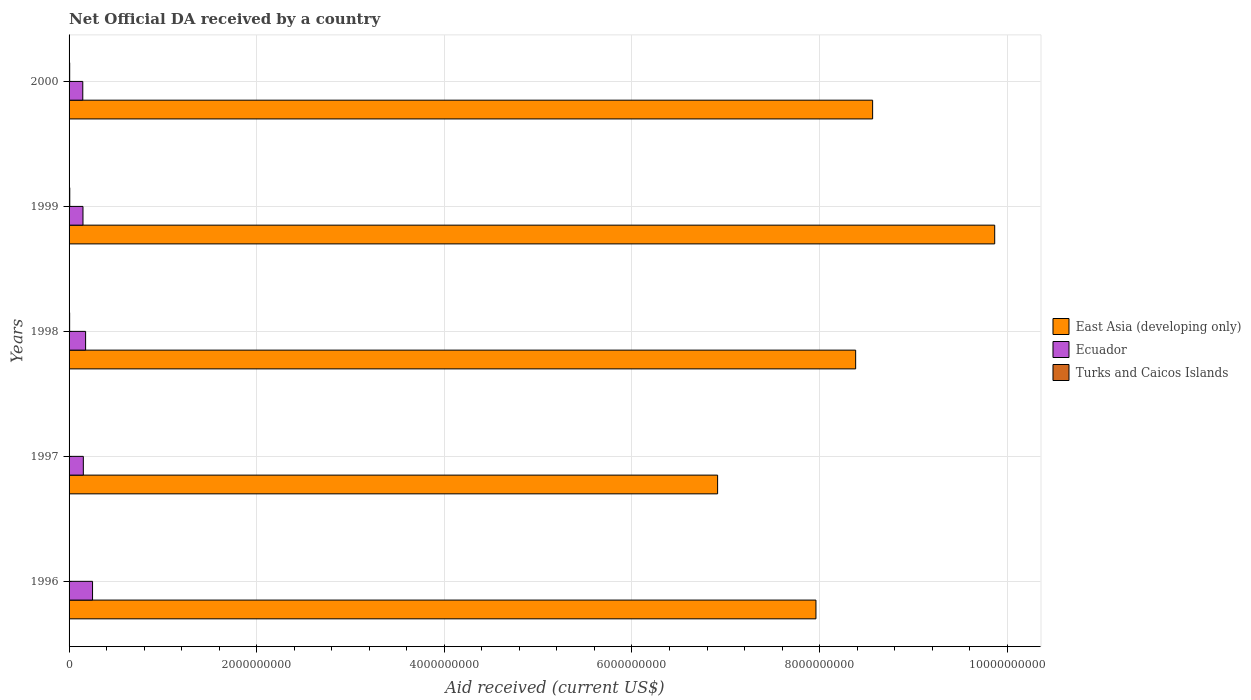What is the net official development assistance aid received in Turks and Caicos Islands in 2000?
Keep it short and to the point. 6.65e+06. Across all years, what is the maximum net official development assistance aid received in East Asia (developing only)?
Your response must be concise. 9.87e+09. Across all years, what is the minimum net official development assistance aid received in Ecuador?
Provide a short and direct response. 1.46e+08. In which year was the net official development assistance aid received in Turks and Caicos Islands maximum?
Provide a succinct answer. 1999. What is the total net official development assistance aid received in Turks and Caicos Islands in the graph?
Offer a very short reply. 2.84e+07. What is the difference between the net official development assistance aid received in East Asia (developing only) in 1996 and that in 2000?
Your answer should be compact. -6.04e+08. What is the difference between the net official development assistance aid received in Turks and Caicos Islands in 1998 and the net official development assistance aid received in East Asia (developing only) in 1999?
Ensure brevity in your answer.  -9.86e+09. What is the average net official development assistance aid received in Turks and Caicos Islands per year?
Keep it short and to the point. 5.69e+06. In the year 2000, what is the difference between the net official development assistance aid received in Ecuador and net official development assistance aid received in East Asia (developing only)?
Give a very brief answer. -8.42e+09. What is the ratio of the net official development assistance aid received in Turks and Caicos Islands in 1996 to that in 2000?
Provide a short and direct response. 0.63. Is the difference between the net official development assistance aid received in Ecuador in 1998 and 1999 greater than the difference between the net official development assistance aid received in East Asia (developing only) in 1998 and 1999?
Your response must be concise. Yes. What is the difference between the highest and the second highest net official development assistance aid received in Ecuador?
Provide a succinct answer. 7.38e+07. What is the difference between the highest and the lowest net official development assistance aid received in Turks and Caicos Islands?
Provide a short and direct response. 3.20e+06. What does the 3rd bar from the top in 1997 represents?
Offer a very short reply. East Asia (developing only). What does the 1st bar from the bottom in 1999 represents?
Your answer should be compact. East Asia (developing only). How many years are there in the graph?
Offer a terse response. 5. What is the difference between two consecutive major ticks on the X-axis?
Keep it short and to the point. 2.00e+09. Are the values on the major ticks of X-axis written in scientific E-notation?
Your response must be concise. No. Does the graph contain any zero values?
Offer a very short reply. No. How many legend labels are there?
Offer a terse response. 3. What is the title of the graph?
Offer a terse response. Net Official DA received by a country. Does "Sub-Saharan Africa (developing only)" appear as one of the legend labels in the graph?
Provide a succinct answer. No. What is the label or title of the X-axis?
Provide a succinct answer. Aid received (current US$). What is the label or title of the Y-axis?
Offer a very short reply. Years. What is the Aid received (current US$) of East Asia (developing only) in 1996?
Offer a terse response. 7.96e+09. What is the Aid received (current US$) of Ecuador in 1996?
Provide a short and direct response. 2.50e+08. What is the Aid received (current US$) of Turks and Caicos Islands in 1996?
Your response must be concise. 4.18e+06. What is the Aid received (current US$) of East Asia (developing only) in 1997?
Give a very brief answer. 6.91e+09. What is the Aid received (current US$) in Ecuador in 1997?
Your answer should be compact. 1.52e+08. What is the Aid received (current US$) of Turks and Caicos Islands in 1997?
Your answer should be very brief. 4.20e+06. What is the Aid received (current US$) in East Asia (developing only) in 1998?
Provide a succinct answer. 8.38e+09. What is the Aid received (current US$) in Ecuador in 1998?
Keep it short and to the point. 1.76e+08. What is the Aid received (current US$) of Turks and Caicos Islands in 1998?
Your response must be concise. 6.02e+06. What is the Aid received (current US$) of East Asia (developing only) in 1999?
Provide a succinct answer. 9.87e+09. What is the Aid received (current US$) of Ecuador in 1999?
Give a very brief answer. 1.48e+08. What is the Aid received (current US$) in Turks and Caicos Islands in 1999?
Make the answer very short. 7.38e+06. What is the Aid received (current US$) in East Asia (developing only) in 2000?
Offer a very short reply. 8.57e+09. What is the Aid received (current US$) in Ecuador in 2000?
Your answer should be very brief. 1.46e+08. What is the Aid received (current US$) in Turks and Caicos Islands in 2000?
Keep it short and to the point. 6.65e+06. Across all years, what is the maximum Aid received (current US$) of East Asia (developing only)?
Your response must be concise. 9.87e+09. Across all years, what is the maximum Aid received (current US$) in Ecuador?
Ensure brevity in your answer.  2.50e+08. Across all years, what is the maximum Aid received (current US$) of Turks and Caicos Islands?
Provide a short and direct response. 7.38e+06. Across all years, what is the minimum Aid received (current US$) of East Asia (developing only)?
Your answer should be compact. 6.91e+09. Across all years, what is the minimum Aid received (current US$) in Ecuador?
Offer a very short reply. 1.46e+08. Across all years, what is the minimum Aid received (current US$) of Turks and Caicos Islands?
Keep it short and to the point. 4.18e+06. What is the total Aid received (current US$) in East Asia (developing only) in the graph?
Ensure brevity in your answer.  4.17e+1. What is the total Aid received (current US$) in Ecuador in the graph?
Keep it short and to the point. 8.73e+08. What is the total Aid received (current US$) in Turks and Caicos Islands in the graph?
Your response must be concise. 2.84e+07. What is the difference between the Aid received (current US$) in East Asia (developing only) in 1996 and that in 1997?
Provide a short and direct response. 1.05e+09. What is the difference between the Aid received (current US$) of Ecuador in 1996 and that in 1997?
Give a very brief answer. 9.82e+07. What is the difference between the Aid received (current US$) of Turks and Caicos Islands in 1996 and that in 1997?
Make the answer very short. -2.00e+04. What is the difference between the Aid received (current US$) of East Asia (developing only) in 1996 and that in 1998?
Give a very brief answer. -4.23e+08. What is the difference between the Aid received (current US$) in Ecuador in 1996 and that in 1998?
Offer a terse response. 7.38e+07. What is the difference between the Aid received (current US$) in Turks and Caicos Islands in 1996 and that in 1998?
Your answer should be compact. -1.84e+06. What is the difference between the Aid received (current US$) in East Asia (developing only) in 1996 and that in 1999?
Offer a terse response. -1.91e+09. What is the difference between the Aid received (current US$) in Ecuador in 1996 and that in 1999?
Offer a very short reply. 1.02e+08. What is the difference between the Aid received (current US$) of Turks and Caicos Islands in 1996 and that in 1999?
Your answer should be very brief. -3.20e+06. What is the difference between the Aid received (current US$) in East Asia (developing only) in 1996 and that in 2000?
Provide a short and direct response. -6.04e+08. What is the difference between the Aid received (current US$) in Ecuador in 1996 and that in 2000?
Your response must be concise. 1.04e+08. What is the difference between the Aid received (current US$) of Turks and Caicos Islands in 1996 and that in 2000?
Make the answer very short. -2.47e+06. What is the difference between the Aid received (current US$) in East Asia (developing only) in 1997 and that in 1998?
Give a very brief answer. -1.47e+09. What is the difference between the Aid received (current US$) in Ecuador in 1997 and that in 1998?
Give a very brief answer. -2.43e+07. What is the difference between the Aid received (current US$) in Turks and Caicos Islands in 1997 and that in 1998?
Keep it short and to the point. -1.82e+06. What is the difference between the Aid received (current US$) in East Asia (developing only) in 1997 and that in 1999?
Keep it short and to the point. -2.95e+09. What is the difference between the Aid received (current US$) of Ecuador in 1997 and that in 1999?
Your answer should be very brief. 3.79e+06. What is the difference between the Aid received (current US$) of Turks and Caicos Islands in 1997 and that in 1999?
Keep it short and to the point. -3.18e+06. What is the difference between the Aid received (current US$) in East Asia (developing only) in 1997 and that in 2000?
Your response must be concise. -1.65e+09. What is the difference between the Aid received (current US$) of Ecuador in 1997 and that in 2000?
Your response must be concise. 5.88e+06. What is the difference between the Aid received (current US$) in Turks and Caicos Islands in 1997 and that in 2000?
Your response must be concise. -2.45e+06. What is the difference between the Aid received (current US$) of East Asia (developing only) in 1998 and that in 1999?
Your answer should be very brief. -1.48e+09. What is the difference between the Aid received (current US$) of Ecuador in 1998 and that in 1999?
Ensure brevity in your answer.  2.81e+07. What is the difference between the Aid received (current US$) in Turks and Caicos Islands in 1998 and that in 1999?
Your response must be concise. -1.36e+06. What is the difference between the Aid received (current US$) in East Asia (developing only) in 1998 and that in 2000?
Your response must be concise. -1.81e+08. What is the difference between the Aid received (current US$) in Ecuador in 1998 and that in 2000?
Ensure brevity in your answer.  3.02e+07. What is the difference between the Aid received (current US$) of Turks and Caicos Islands in 1998 and that in 2000?
Offer a terse response. -6.30e+05. What is the difference between the Aid received (current US$) of East Asia (developing only) in 1999 and that in 2000?
Offer a terse response. 1.30e+09. What is the difference between the Aid received (current US$) of Ecuador in 1999 and that in 2000?
Provide a succinct answer. 2.09e+06. What is the difference between the Aid received (current US$) of Turks and Caicos Islands in 1999 and that in 2000?
Offer a terse response. 7.30e+05. What is the difference between the Aid received (current US$) in East Asia (developing only) in 1996 and the Aid received (current US$) in Ecuador in 1997?
Your answer should be compact. 7.81e+09. What is the difference between the Aid received (current US$) in East Asia (developing only) in 1996 and the Aid received (current US$) in Turks and Caicos Islands in 1997?
Make the answer very short. 7.96e+09. What is the difference between the Aid received (current US$) in Ecuador in 1996 and the Aid received (current US$) in Turks and Caicos Islands in 1997?
Your response must be concise. 2.46e+08. What is the difference between the Aid received (current US$) of East Asia (developing only) in 1996 and the Aid received (current US$) of Ecuador in 1998?
Make the answer very short. 7.78e+09. What is the difference between the Aid received (current US$) in East Asia (developing only) in 1996 and the Aid received (current US$) in Turks and Caicos Islands in 1998?
Provide a short and direct response. 7.96e+09. What is the difference between the Aid received (current US$) in Ecuador in 1996 and the Aid received (current US$) in Turks and Caicos Islands in 1998?
Offer a terse response. 2.44e+08. What is the difference between the Aid received (current US$) in East Asia (developing only) in 1996 and the Aid received (current US$) in Ecuador in 1999?
Your answer should be very brief. 7.81e+09. What is the difference between the Aid received (current US$) in East Asia (developing only) in 1996 and the Aid received (current US$) in Turks and Caicos Islands in 1999?
Ensure brevity in your answer.  7.95e+09. What is the difference between the Aid received (current US$) of Ecuador in 1996 and the Aid received (current US$) of Turks and Caicos Islands in 1999?
Your answer should be very brief. 2.43e+08. What is the difference between the Aid received (current US$) of East Asia (developing only) in 1996 and the Aid received (current US$) of Ecuador in 2000?
Provide a short and direct response. 7.82e+09. What is the difference between the Aid received (current US$) of East Asia (developing only) in 1996 and the Aid received (current US$) of Turks and Caicos Islands in 2000?
Provide a short and direct response. 7.95e+09. What is the difference between the Aid received (current US$) of Ecuador in 1996 and the Aid received (current US$) of Turks and Caicos Islands in 2000?
Make the answer very short. 2.44e+08. What is the difference between the Aid received (current US$) in East Asia (developing only) in 1997 and the Aid received (current US$) in Ecuador in 1998?
Your answer should be very brief. 6.74e+09. What is the difference between the Aid received (current US$) in East Asia (developing only) in 1997 and the Aid received (current US$) in Turks and Caicos Islands in 1998?
Your response must be concise. 6.91e+09. What is the difference between the Aid received (current US$) of Ecuador in 1997 and the Aid received (current US$) of Turks and Caicos Islands in 1998?
Provide a succinct answer. 1.46e+08. What is the difference between the Aid received (current US$) in East Asia (developing only) in 1997 and the Aid received (current US$) in Ecuador in 1999?
Offer a terse response. 6.76e+09. What is the difference between the Aid received (current US$) in East Asia (developing only) in 1997 and the Aid received (current US$) in Turks and Caicos Islands in 1999?
Your answer should be compact. 6.91e+09. What is the difference between the Aid received (current US$) of Ecuador in 1997 and the Aid received (current US$) of Turks and Caicos Islands in 1999?
Offer a terse response. 1.45e+08. What is the difference between the Aid received (current US$) of East Asia (developing only) in 1997 and the Aid received (current US$) of Ecuador in 2000?
Offer a terse response. 6.77e+09. What is the difference between the Aid received (current US$) of East Asia (developing only) in 1997 and the Aid received (current US$) of Turks and Caicos Islands in 2000?
Ensure brevity in your answer.  6.91e+09. What is the difference between the Aid received (current US$) of Ecuador in 1997 and the Aid received (current US$) of Turks and Caicos Islands in 2000?
Make the answer very short. 1.45e+08. What is the difference between the Aid received (current US$) in East Asia (developing only) in 1998 and the Aid received (current US$) in Ecuador in 1999?
Provide a succinct answer. 8.24e+09. What is the difference between the Aid received (current US$) in East Asia (developing only) in 1998 and the Aid received (current US$) in Turks and Caicos Islands in 1999?
Your answer should be compact. 8.38e+09. What is the difference between the Aid received (current US$) in Ecuador in 1998 and the Aid received (current US$) in Turks and Caicos Islands in 1999?
Provide a short and direct response. 1.69e+08. What is the difference between the Aid received (current US$) in East Asia (developing only) in 1998 and the Aid received (current US$) in Ecuador in 2000?
Your response must be concise. 8.24e+09. What is the difference between the Aid received (current US$) in East Asia (developing only) in 1998 and the Aid received (current US$) in Turks and Caicos Islands in 2000?
Your answer should be compact. 8.38e+09. What is the difference between the Aid received (current US$) of Ecuador in 1998 and the Aid received (current US$) of Turks and Caicos Islands in 2000?
Your response must be concise. 1.70e+08. What is the difference between the Aid received (current US$) in East Asia (developing only) in 1999 and the Aid received (current US$) in Ecuador in 2000?
Give a very brief answer. 9.72e+09. What is the difference between the Aid received (current US$) in East Asia (developing only) in 1999 and the Aid received (current US$) in Turks and Caicos Islands in 2000?
Offer a terse response. 9.86e+09. What is the difference between the Aid received (current US$) of Ecuador in 1999 and the Aid received (current US$) of Turks and Caicos Islands in 2000?
Keep it short and to the point. 1.42e+08. What is the average Aid received (current US$) in East Asia (developing only) per year?
Keep it short and to the point. 8.34e+09. What is the average Aid received (current US$) of Ecuador per year?
Keep it short and to the point. 1.75e+08. What is the average Aid received (current US$) of Turks and Caicos Islands per year?
Keep it short and to the point. 5.69e+06. In the year 1996, what is the difference between the Aid received (current US$) of East Asia (developing only) and Aid received (current US$) of Ecuador?
Your response must be concise. 7.71e+09. In the year 1996, what is the difference between the Aid received (current US$) of East Asia (developing only) and Aid received (current US$) of Turks and Caicos Islands?
Your response must be concise. 7.96e+09. In the year 1996, what is the difference between the Aid received (current US$) in Ecuador and Aid received (current US$) in Turks and Caicos Islands?
Keep it short and to the point. 2.46e+08. In the year 1997, what is the difference between the Aid received (current US$) in East Asia (developing only) and Aid received (current US$) in Ecuador?
Your response must be concise. 6.76e+09. In the year 1997, what is the difference between the Aid received (current US$) of East Asia (developing only) and Aid received (current US$) of Turks and Caicos Islands?
Provide a succinct answer. 6.91e+09. In the year 1997, what is the difference between the Aid received (current US$) in Ecuador and Aid received (current US$) in Turks and Caicos Islands?
Provide a succinct answer. 1.48e+08. In the year 1998, what is the difference between the Aid received (current US$) in East Asia (developing only) and Aid received (current US$) in Ecuador?
Ensure brevity in your answer.  8.21e+09. In the year 1998, what is the difference between the Aid received (current US$) of East Asia (developing only) and Aid received (current US$) of Turks and Caicos Islands?
Provide a succinct answer. 8.38e+09. In the year 1998, what is the difference between the Aid received (current US$) in Ecuador and Aid received (current US$) in Turks and Caicos Islands?
Keep it short and to the point. 1.70e+08. In the year 1999, what is the difference between the Aid received (current US$) in East Asia (developing only) and Aid received (current US$) in Ecuador?
Offer a very short reply. 9.72e+09. In the year 1999, what is the difference between the Aid received (current US$) of East Asia (developing only) and Aid received (current US$) of Turks and Caicos Islands?
Ensure brevity in your answer.  9.86e+09. In the year 1999, what is the difference between the Aid received (current US$) of Ecuador and Aid received (current US$) of Turks and Caicos Islands?
Give a very brief answer. 1.41e+08. In the year 2000, what is the difference between the Aid received (current US$) in East Asia (developing only) and Aid received (current US$) in Ecuador?
Your answer should be very brief. 8.42e+09. In the year 2000, what is the difference between the Aid received (current US$) in East Asia (developing only) and Aid received (current US$) in Turks and Caicos Islands?
Give a very brief answer. 8.56e+09. In the year 2000, what is the difference between the Aid received (current US$) in Ecuador and Aid received (current US$) in Turks and Caicos Islands?
Ensure brevity in your answer.  1.39e+08. What is the ratio of the Aid received (current US$) of East Asia (developing only) in 1996 to that in 1997?
Offer a very short reply. 1.15. What is the ratio of the Aid received (current US$) in Ecuador in 1996 to that in 1997?
Provide a short and direct response. 1.65. What is the ratio of the Aid received (current US$) in East Asia (developing only) in 1996 to that in 1998?
Make the answer very short. 0.95. What is the ratio of the Aid received (current US$) in Ecuador in 1996 to that in 1998?
Provide a short and direct response. 1.42. What is the ratio of the Aid received (current US$) of Turks and Caicos Islands in 1996 to that in 1998?
Provide a short and direct response. 0.69. What is the ratio of the Aid received (current US$) in East Asia (developing only) in 1996 to that in 1999?
Keep it short and to the point. 0.81. What is the ratio of the Aid received (current US$) in Ecuador in 1996 to that in 1999?
Provide a succinct answer. 1.69. What is the ratio of the Aid received (current US$) of Turks and Caicos Islands in 1996 to that in 1999?
Provide a short and direct response. 0.57. What is the ratio of the Aid received (current US$) of East Asia (developing only) in 1996 to that in 2000?
Offer a terse response. 0.93. What is the ratio of the Aid received (current US$) of Ecuador in 1996 to that in 2000?
Your response must be concise. 1.71. What is the ratio of the Aid received (current US$) in Turks and Caicos Islands in 1996 to that in 2000?
Your answer should be compact. 0.63. What is the ratio of the Aid received (current US$) in East Asia (developing only) in 1997 to that in 1998?
Offer a very short reply. 0.82. What is the ratio of the Aid received (current US$) in Ecuador in 1997 to that in 1998?
Your response must be concise. 0.86. What is the ratio of the Aid received (current US$) of Turks and Caicos Islands in 1997 to that in 1998?
Give a very brief answer. 0.7. What is the ratio of the Aid received (current US$) in East Asia (developing only) in 1997 to that in 1999?
Offer a terse response. 0.7. What is the ratio of the Aid received (current US$) of Ecuador in 1997 to that in 1999?
Offer a very short reply. 1.03. What is the ratio of the Aid received (current US$) of Turks and Caicos Islands in 1997 to that in 1999?
Provide a succinct answer. 0.57. What is the ratio of the Aid received (current US$) in East Asia (developing only) in 1997 to that in 2000?
Make the answer very short. 0.81. What is the ratio of the Aid received (current US$) of Ecuador in 1997 to that in 2000?
Make the answer very short. 1.04. What is the ratio of the Aid received (current US$) in Turks and Caicos Islands in 1997 to that in 2000?
Ensure brevity in your answer.  0.63. What is the ratio of the Aid received (current US$) of East Asia (developing only) in 1998 to that in 1999?
Keep it short and to the point. 0.85. What is the ratio of the Aid received (current US$) in Ecuador in 1998 to that in 1999?
Your answer should be very brief. 1.19. What is the ratio of the Aid received (current US$) of Turks and Caicos Islands in 1998 to that in 1999?
Keep it short and to the point. 0.82. What is the ratio of the Aid received (current US$) of East Asia (developing only) in 1998 to that in 2000?
Provide a succinct answer. 0.98. What is the ratio of the Aid received (current US$) of Ecuador in 1998 to that in 2000?
Give a very brief answer. 1.21. What is the ratio of the Aid received (current US$) in Turks and Caicos Islands in 1998 to that in 2000?
Your response must be concise. 0.91. What is the ratio of the Aid received (current US$) in East Asia (developing only) in 1999 to that in 2000?
Give a very brief answer. 1.15. What is the ratio of the Aid received (current US$) in Ecuador in 1999 to that in 2000?
Your answer should be compact. 1.01. What is the ratio of the Aid received (current US$) in Turks and Caicos Islands in 1999 to that in 2000?
Ensure brevity in your answer.  1.11. What is the difference between the highest and the second highest Aid received (current US$) of East Asia (developing only)?
Keep it short and to the point. 1.30e+09. What is the difference between the highest and the second highest Aid received (current US$) of Ecuador?
Your response must be concise. 7.38e+07. What is the difference between the highest and the second highest Aid received (current US$) of Turks and Caicos Islands?
Make the answer very short. 7.30e+05. What is the difference between the highest and the lowest Aid received (current US$) in East Asia (developing only)?
Offer a very short reply. 2.95e+09. What is the difference between the highest and the lowest Aid received (current US$) of Ecuador?
Ensure brevity in your answer.  1.04e+08. What is the difference between the highest and the lowest Aid received (current US$) of Turks and Caicos Islands?
Offer a terse response. 3.20e+06. 